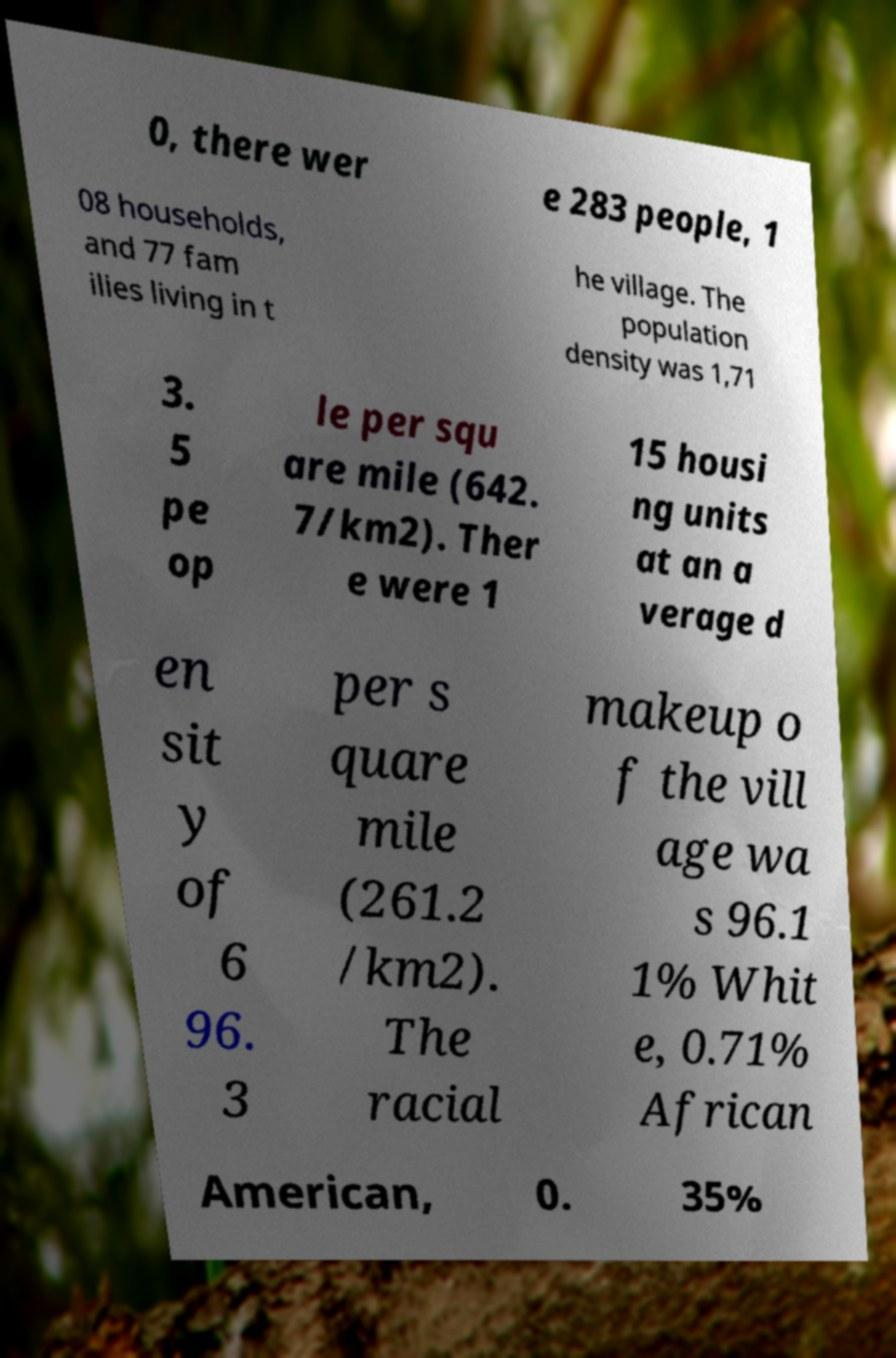Please read and relay the text visible in this image. What does it say? 0, there wer e 283 people, 1 08 households, and 77 fam ilies living in t he village. The population density was 1,71 3. 5 pe op le per squ are mile (642. 7/km2). Ther e were 1 15 housi ng units at an a verage d en sit y of 6 96. 3 per s quare mile (261.2 /km2). The racial makeup o f the vill age wa s 96.1 1% Whit e, 0.71% African American, 0. 35% 